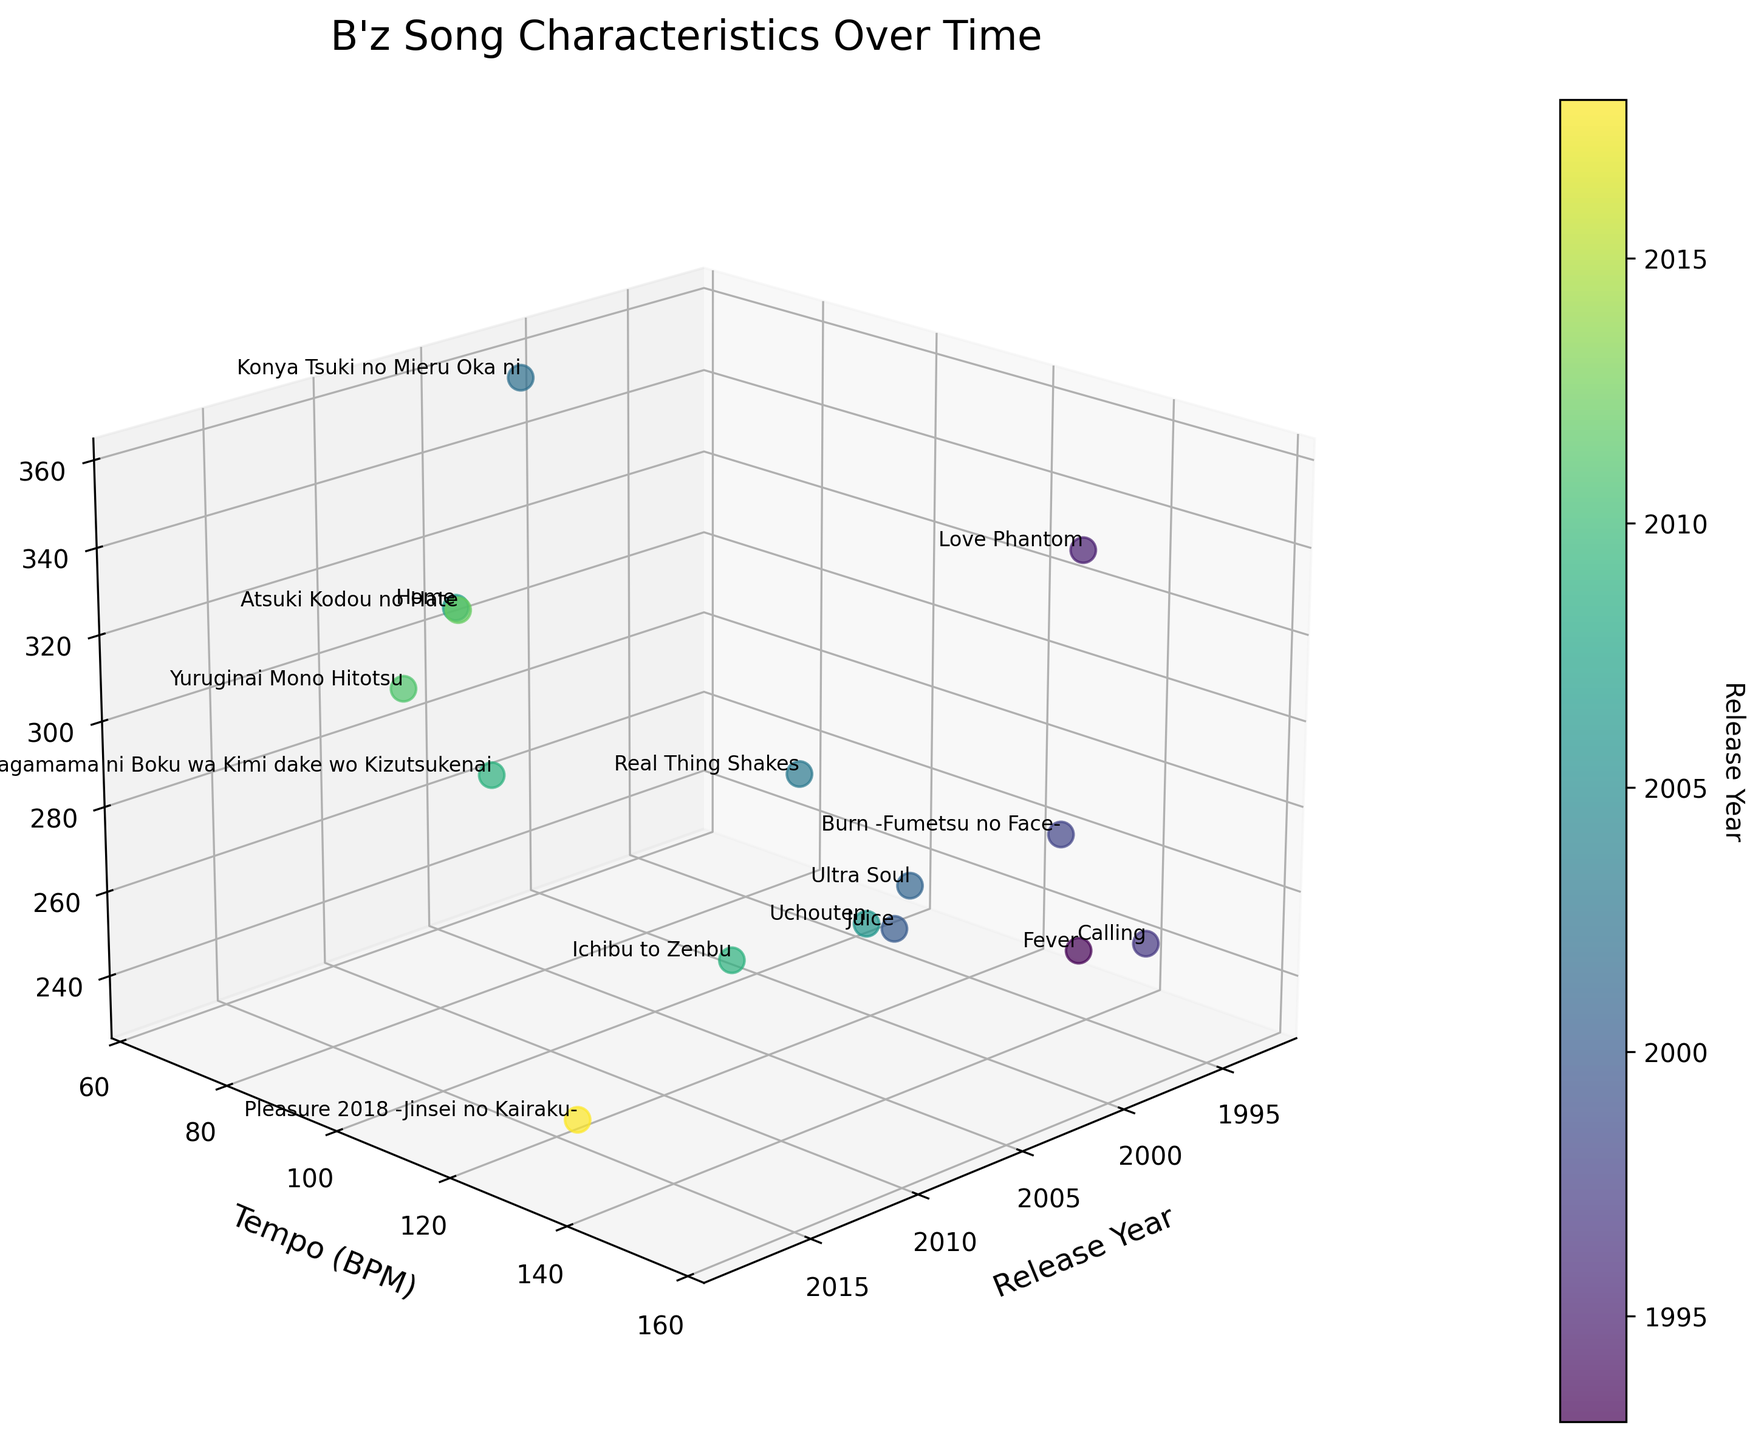How many songs are plotted in the figure? Count the number of different songs labeled in the scatter plot.
Answer: 15 What is the range of release years shown in the plot? Identify the earliest and the latest release years from the plot.
Answer: 1993 to 2018 Which song has the fastest tempo and what is its tempo? Locate the song with the highest BPM value on the y-axis.
Answer: Calling, 156 BPM Which year has the most variation in song lengths? Look for a year where the z-values (song lengths) are most spread out vertically.
Answer: 2009 What is the longest song in terms of duration, and how long is it? Identify the highest z-coordinate (song length) on the plot.
Answer: Konya Tsuki no Mieru Oka ni, 5 minutes and 56 seconds Between "Ai no Mama ni Wagamama ni Boku wa Kimi dake wo Kizutsukenai" and "Ichibu to Zenbu," which song is longer, and by how much? Match the z-values for both songs and calculate the difference.
Answer: Ai no Mama ni Wagamama ni Boku wa Kimi dake wo Kizutsukenai, longer by 23 seconds How do the tempo and length of songs from the year 2009 compare to those from the year 1997? Analyze the x-coordinates for 2009 and 1997, and compare their y (tempo) and z (length) values.
Answer: 2009 songs have lower tempos and varying lengths, 1997 songs have higher tempos Which song released in the 2000s is the shortest in duration? Find the song with the lowest z-coordinate (shortest length) among those released between 2000-2009.
Answer: Juice, 4 minutes and 8 seconds Is there an upward or downward trend in the tempo of B'z songs over the years? Observe the pattern of the scatter points along the x (year) and y (tempo) axes.
Answer: No clear trend What is the average tempo of songs released after 2010? Identify songs released after 2010, sum their tempos, and divide by the count of these songs.
Answer: (92 + 78 + 135) / 3 = 101.7 BPM 